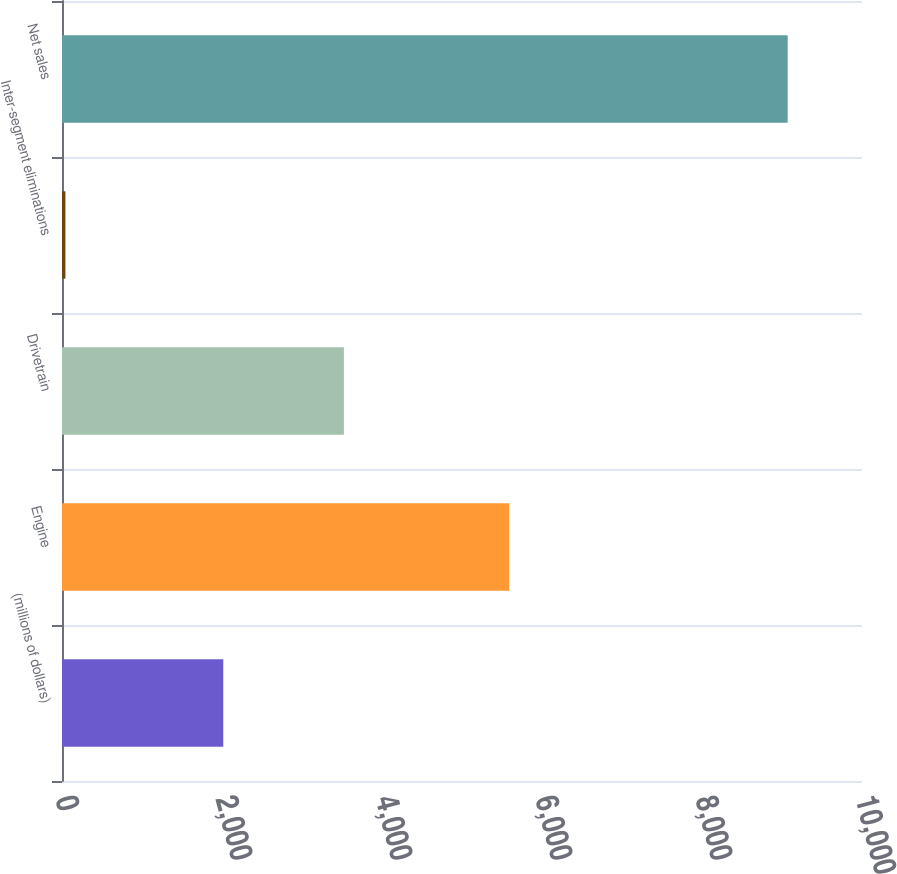Convert chart to OTSL. <chart><loc_0><loc_0><loc_500><loc_500><bar_chart><fcel>(millions of dollars)<fcel>Engine<fcel>Drivetrain<fcel>Inter-segment eliminations<fcel>Net sales<nl><fcel>2016<fcel>5590.1<fcel>3523.7<fcel>42.8<fcel>9071<nl></chart> 